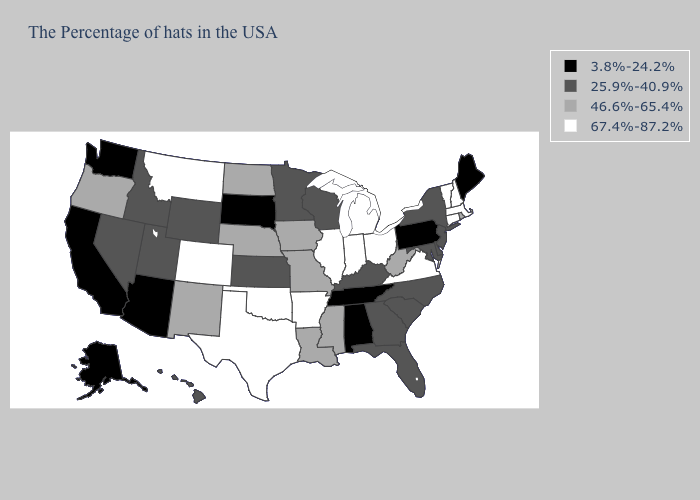Does Wyoming have the same value as Hawaii?
Write a very short answer. Yes. Does Colorado have the highest value in the West?
Quick response, please. Yes. Does Delaware have a lower value than New York?
Give a very brief answer. No. Name the states that have a value in the range 3.8%-24.2%?
Quick response, please. Maine, Pennsylvania, Alabama, Tennessee, South Dakota, Arizona, California, Washington, Alaska. Name the states that have a value in the range 3.8%-24.2%?
Short answer required. Maine, Pennsylvania, Alabama, Tennessee, South Dakota, Arizona, California, Washington, Alaska. Does Massachusetts have the highest value in the Northeast?
Short answer required. Yes. Name the states that have a value in the range 46.6%-65.4%?
Concise answer only. Rhode Island, West Virginia, Mississippi, Louisiana, Missouri, Iowa, Nebraska, North Dakota, New Mexico, Oregon. What is the lowest value in the South?
Quick response, please. 3.8%-24.2%. Does North Dakota have a higher value than Wisconsin?
Answer briefly. Yes. What is the highest value in the USA?
Concise answer only. 67.4%-87.2%. Name the states that have a value in the range 25.9%-40.9%?
Give a very brief answer. New York, New Jersey, Delaware, Maryland, North Carolina, South Carolina, Florida, Georgia, Kentucky, Wisconsin, Minnesota, Kansas, Wyoming, Utah, Idaho, Nevada, Hawaii. Which states have the lowest value in the USA?
Give a very brief answer. Maine, Pennsylvania, Alabama, Tennessee, South Dakota, Arizona, California, Washington, Alaska. Among the states that border Delaware , does Maryland have the highest value?
Answer briefly. Yes. Does Oklahoma have the lowest value in the South?
Keep it brief. No. Name the states that have a value in the range 67.4%-87.2%?
Give a very brief answer. Massachusetts, New Hampshire, Vermont, Connecticut, Virginia, Ohio, Michigan, Indiana, Illinois, Arkansas, Oklahoma, Texas, Colorado, Montana. 